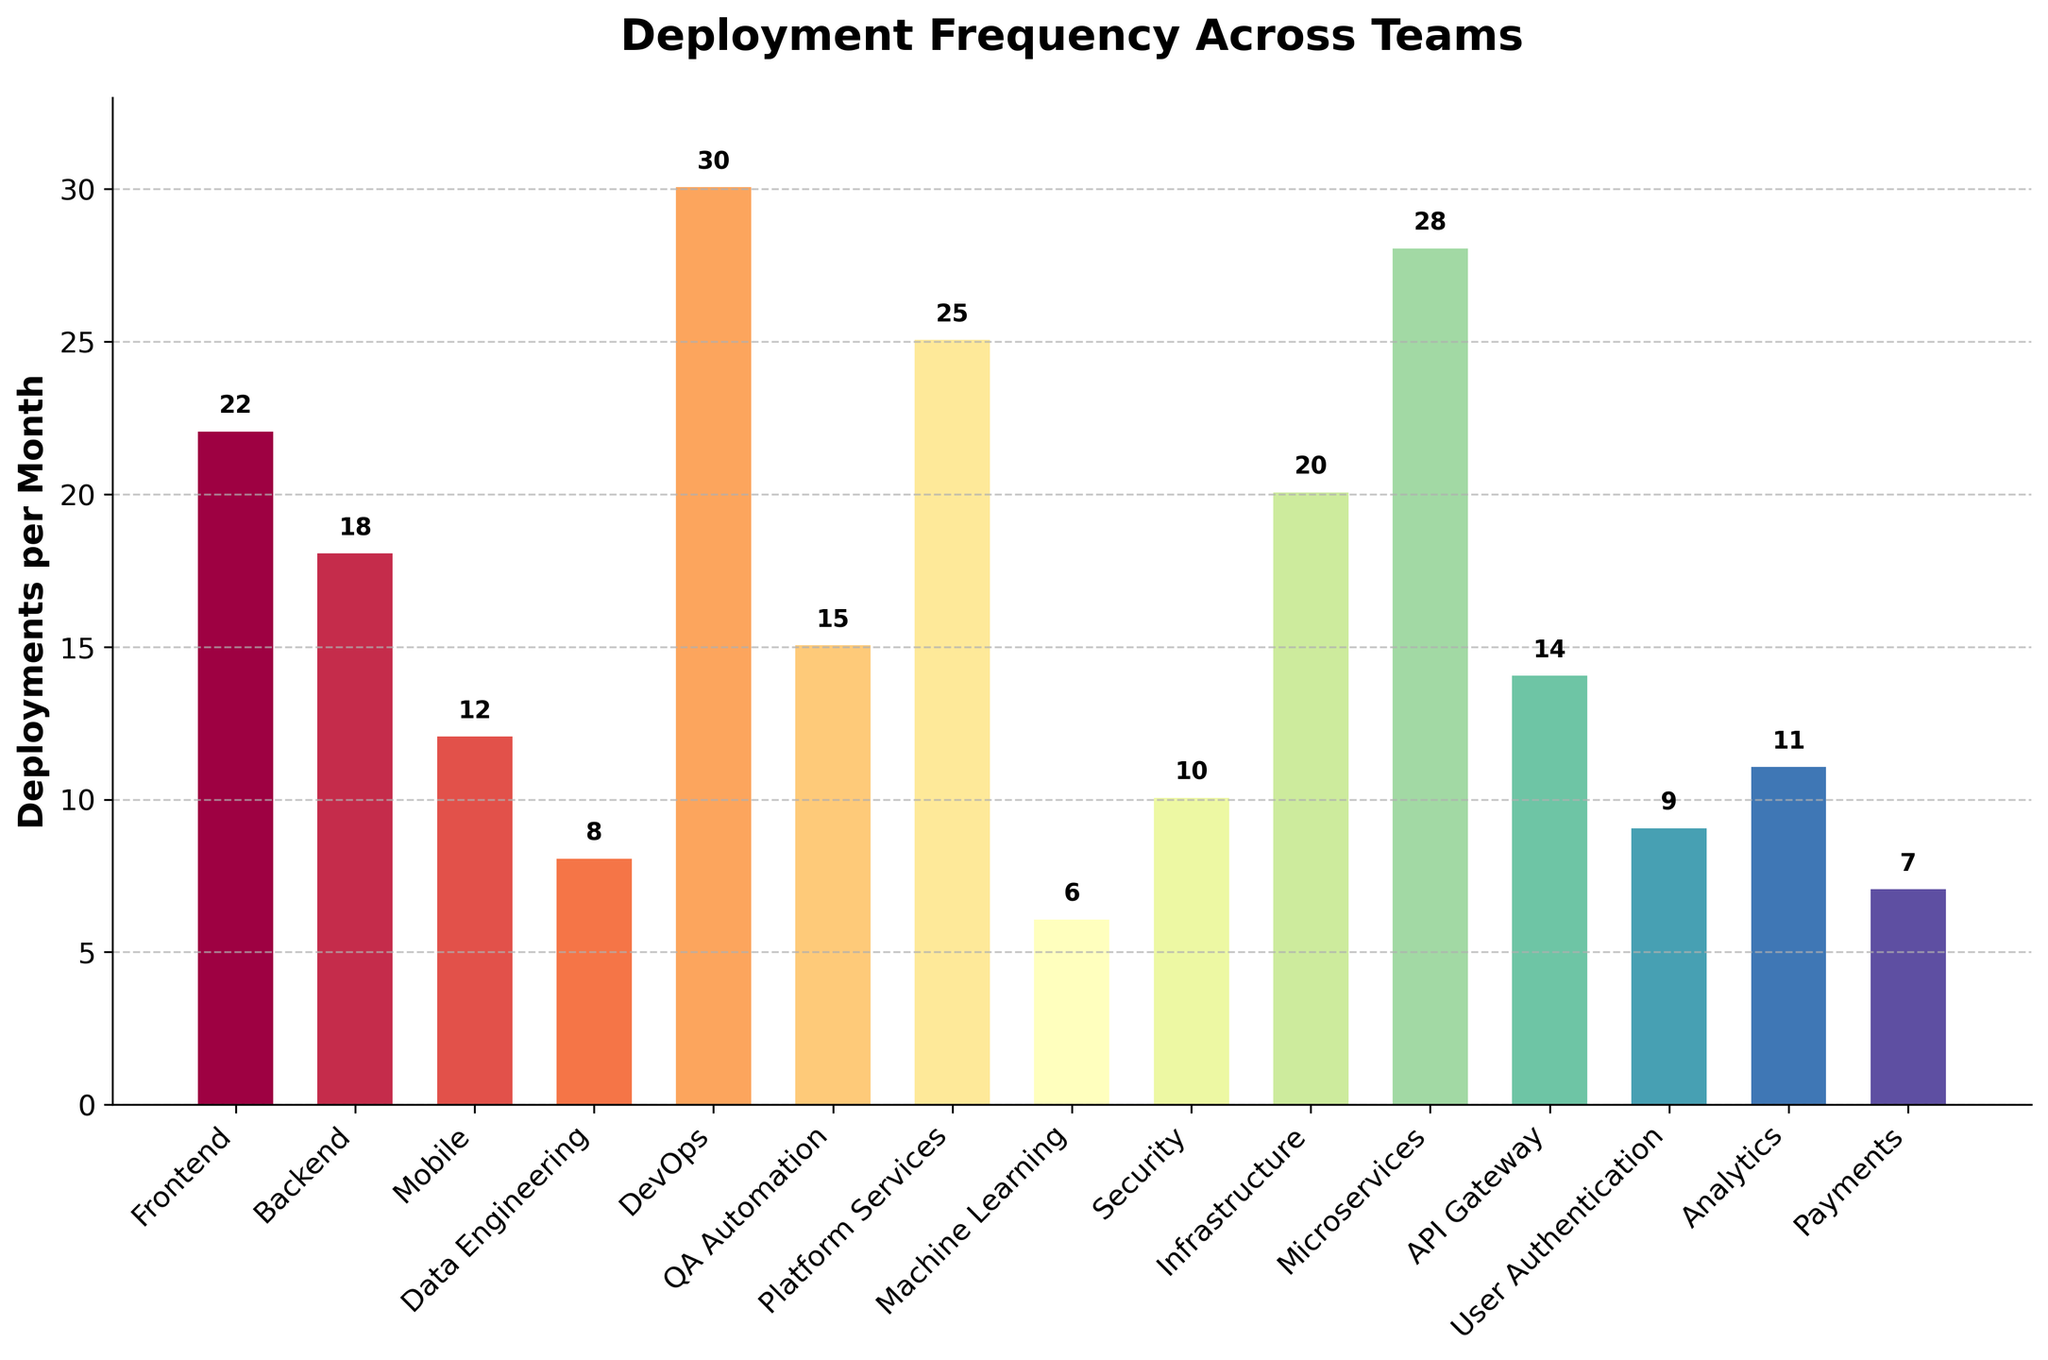What team has the highest number of deployments per month? The figure shows a bar for each team, and the height of the bar represents the number of deployments per month. The tallest bar corresponds to the team with the highest number of deployments, which is DevOps with 30 deployments per month.
Answer: DevOps Which team has the lowest number of deployments per month? The figure displays bars of varying heights. The shortest bar indicates the team with the fewest deployments, which is Machine Learning with 6 deployments per month.
Answer: Machine Learning What is the total number of deployments per month for the Data Engineering and Payments teams combined? We find the heights of the bars for Data Engineering and Payments, which are 8 and 7 respectively. Adding these values gives 8 + 7 = 15.
Answer: 15 Compare the number of deployments per month between the Frontend team and the Backend team. The height of the bar for Frontend is 22 and for Backend is 18. By comparing these numbers, we see that the Frontend team has more deployments than the Backend team.
Answer: Frontend has more What is the average number of deployments per month across all teams? To calculate the average, sum all the deployment counts and then divide by the number of teams. The total sum is 22 + 18 + 12 + 8 + 30 + 15 + 25 + 6 + 10 + 20 + 28 + 14 + 9 + 11 + 7 = 235. There are 15 teams. So, the average is 235 / 15 ≈ 15.67.
Answer: 15.67 What is the difference in deployment frequency between the DevOps and Security teams? Identify the deployment numbers for DevOps and Security, which are 30 and 10 respectively. Subtract the two values: 30 - 10 = 20.
Answer: 20 Which team has a deployment frequency closest to the median value of all teams? First, arrange the deployment values in ascending order: 6, 7, 8, 9, 10, 11, 12, 14, 15, 18, 20, 22, 25, 28, 30. The median value is the middle value in this sorted list since there is an odd number of teams, which is 14. The team with 14 deployments per month is API Gateway.
Answer: API Gateway What color is the bar representing the Backend team likely to be? The bar plot uses a spectral color gradient, transitioning smoothly from one color to the next. Since the Backend team is the second bar from the left, its color would be near the start of the gradient, likely a lighter shade.
Answer: A lighter shade (such as light green or yellow) How many teams have a deployment frequency greater than 20 deployments per month? Count the bars with heights greater than 20. These are the Frontend (22), DevOps (30), Platform Services (25), Microservices (28), and Infrastructure (20).
Answer: 4 Is the number of deployments for the Platform Services team greater than or less than the average number of deployments per team? First, calculate the average number of deployments (15.67). The number of deployments for Platform Services is 25. Compare these numbers to see that 25 is greater than 15.67.
Answer: Greater 